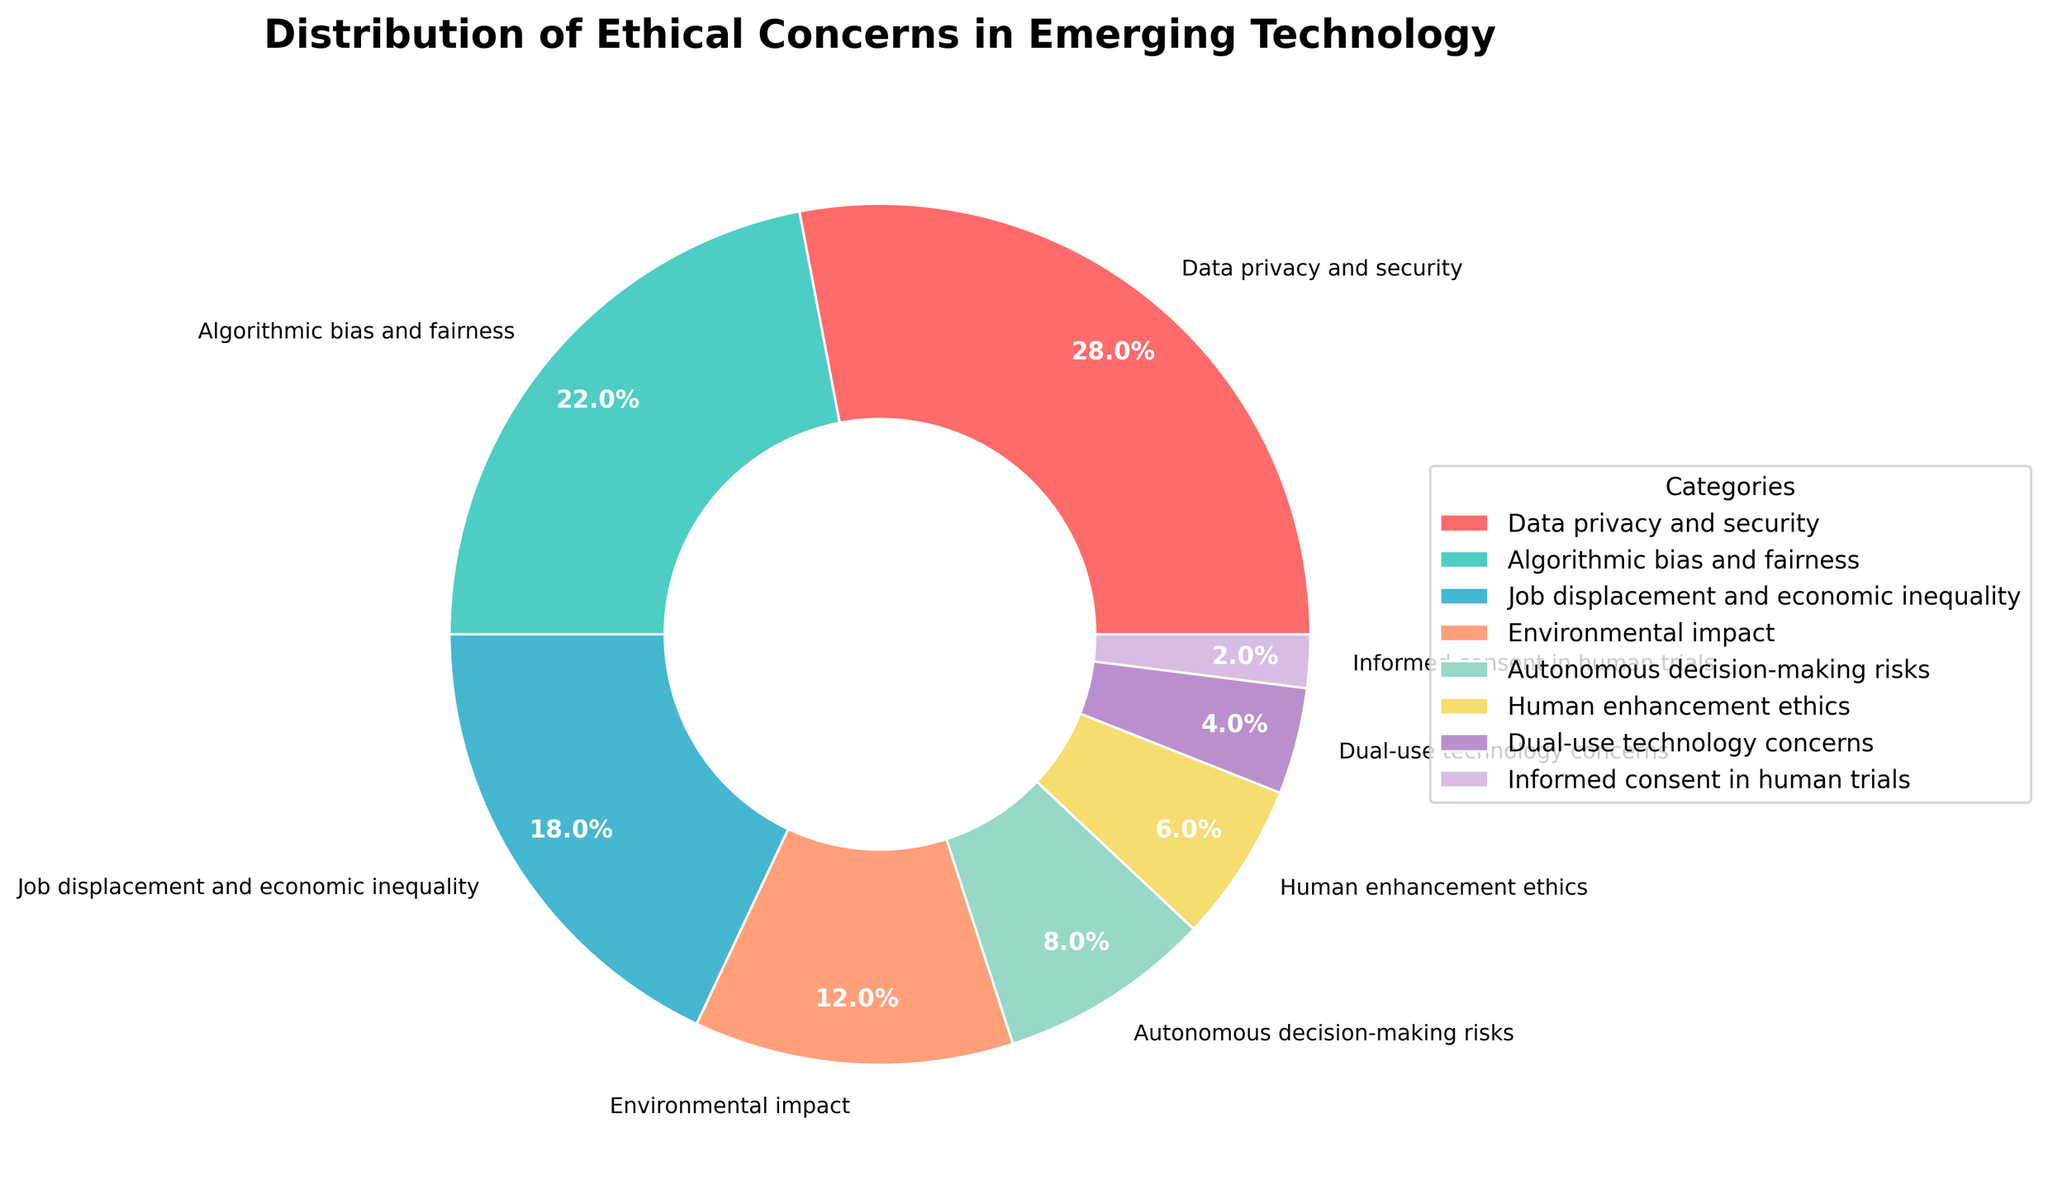What category has the highest percentage of ethical concerns? The category with the highest percentage is easily identified by looking for the largest slice in the pie chart, which represents 28%.
Answer: Data privacy and security Which two categories together make up exactly half (or close to half) of the total percentage of ethical concerns? Adding the percentages of various categories to see which two sum up to or near 50%. The categories 'Data privacy and security' (28%) and 'Algorithmic bias and fairness' (22%) together sum to 50%.
Answer: Data privacy and security and Algorithmic bias and fairness How does the percentage of 'Job displacement and economic inequality' compare to 'Environmental impact'? Compare the sizes of the slices representing 'Job displacement and economic inequality' (18%) and 'Environmental impact' (12%). 'Job displacement and economic inequality' has a larger percentage.
Answer: Job displacement and economic inequality has a higher percentage What is the combined percentage of 'Human enhancement ethics' and 'Informed consent in human trials'? Adding the percentages: 'Human enhancement ethics' (6%) + 'Informed consent in human trials' (2%) = 8%.
Answer: 8% What is the difference in the percentage of concerns between 'Autonomous decision-making risks' and 'Dual-use technology concerns'? Subtract the smaller percentage from the larger one: 'Autonomous decision-making risks' (8%) - 'Dual-use technology concerns' (4%) = 4%.
Answer: 4% Which category has the least percentage of concerns, and what is that percentage? Identify the smallest slice in the pie chart, which represents 2%.
Answer: Informed consent in human trials If you were to combine the categories 'Environmental impact', 'Autonomous decision-making risks', and 'Human enhancement ethics', what would their total percentage be? Adding the percentages: 'Environmental impact' (12%) + 'Autonomous decision-making risks' (8%) + 'Human enhancement ethics' (6%) = 26%.
Answer: 26% Is the percentage of 'Data privacy and security' greater than the combined percentage of 'Autonomous decision-making risks' and 'Human enhancement ethics'? Compare 'Data privacy and security' (28%) with the sum of 'Autonomous decision-making risks' (8%) and 'Human enhancement ethics' (6%), which adds up to 14%. Since 28% > 14%, the answer is yes.
Answer: Yes 